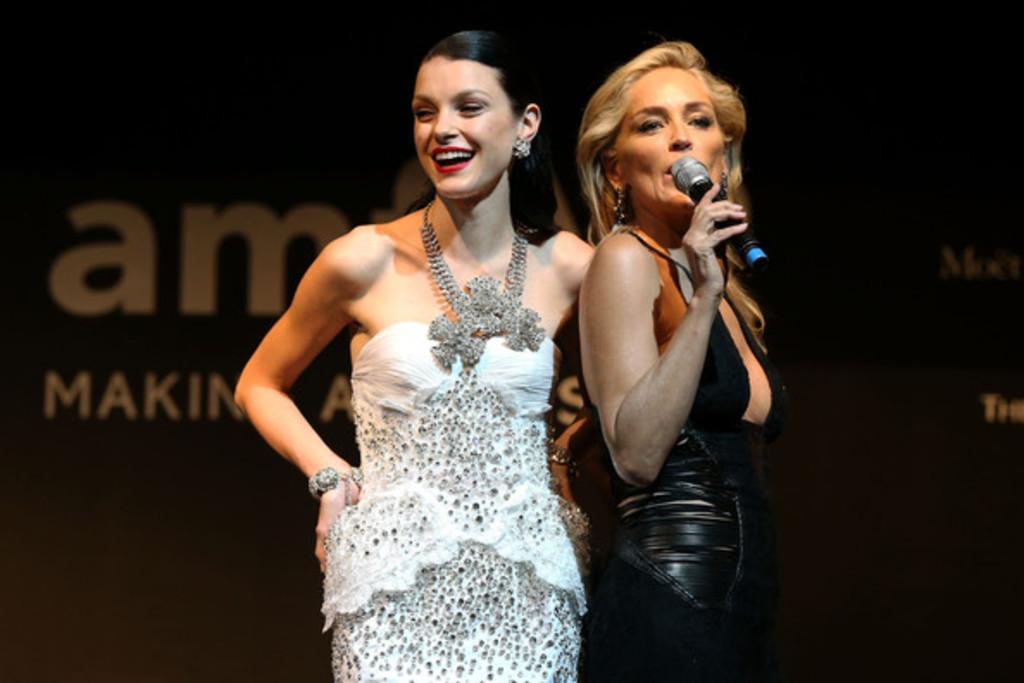Can you describe this image briefly? In this image there is a woman standing , another woman standing and singing a song in the microphone. 